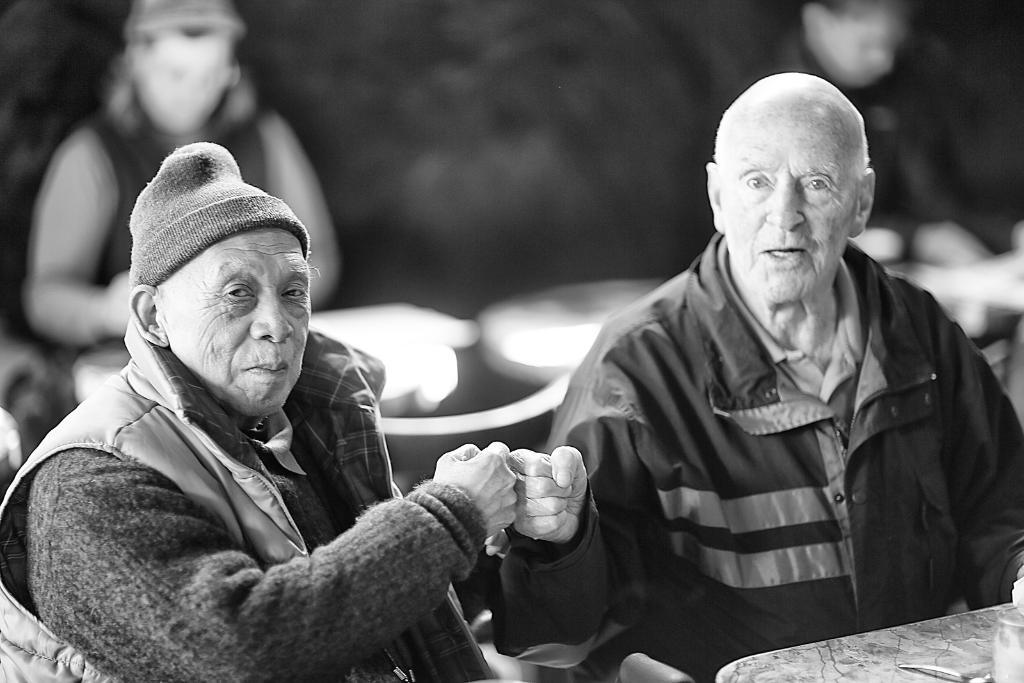What is the color scheme of the image? The image is black and white. What are the people in the image doing? The people are sitting on chairs in the image. What can be found on the table in the image? There is a table with objects in the image. Can you describe the background of the image? The background is blurred in the image. How many ornaments are hanging from the people's heads in the image? There are no ornaments hanging from the people's heads in the image, as it is a black and white image with people sitting on chairs and a table with objects. 